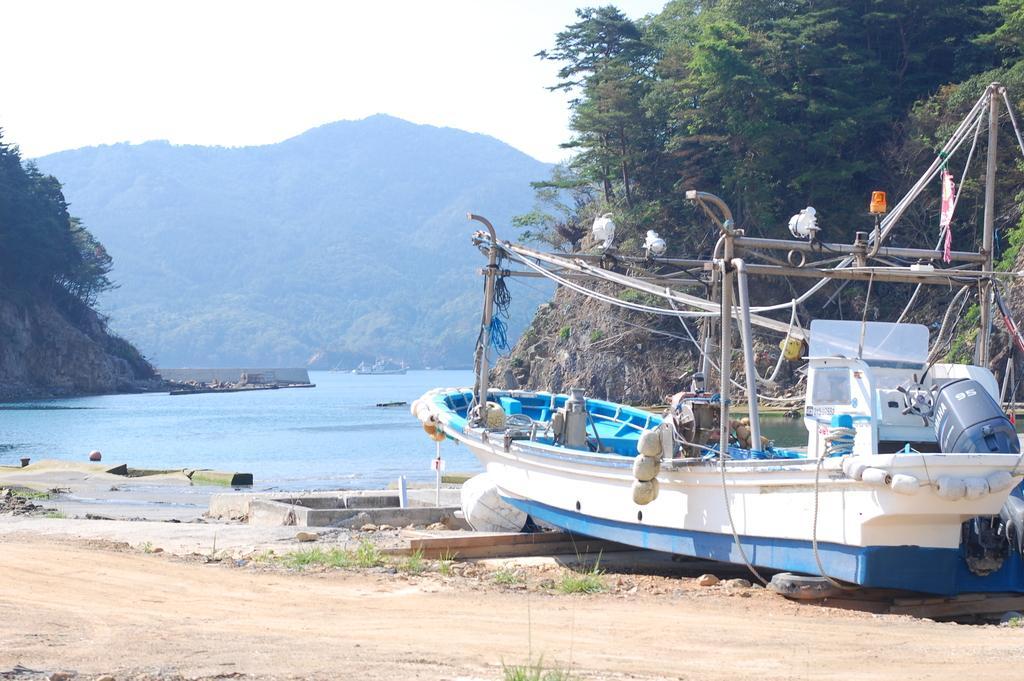Could you give a brief overview of what you see in this image? In the right side it is a boat which is in white color, in the middle this is water and these are the hills. 